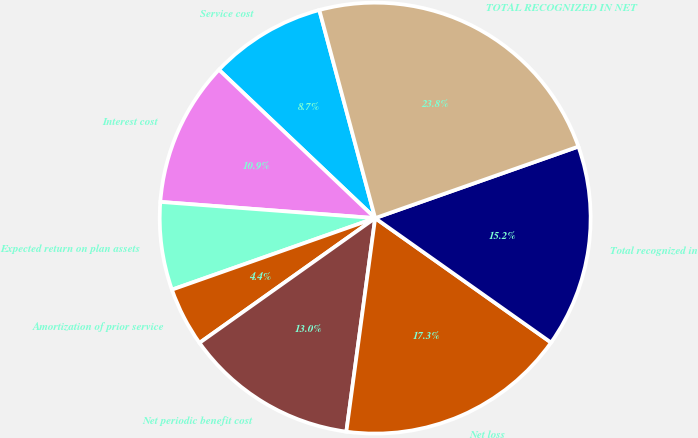Convert chart. <chart><loc_0><loc_0><loc_500><loc_500><pie_chart><fcel>Service cost<fcel>Interest cost<fcel>Expected return on plan assets<fcel>Amortization of prior service<fcel>Net periodic benefit cost<fcel>Net loss<fcel>Total recognized in<fcel>TOTAL RECOGNIZED IN NET<nl><fcel>8.74%<fcel>10.89%<fcel>6.59%<fcel>4.44%<fcel>13.04%<fcel>17.34%<fcel>15.19%<fcel>23.79%<nl></chart> 